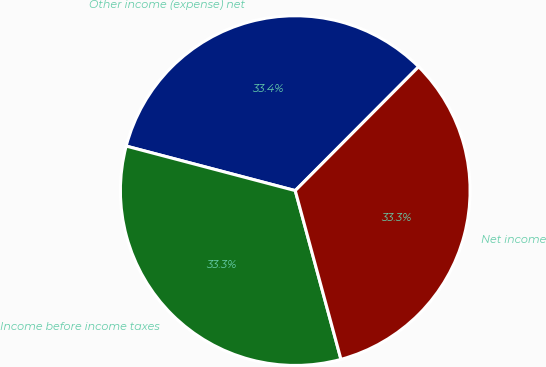Convert chart to OTSL. <chart><loc_0><loc_0><loc_500><loc_500><pie_chart><fcel>Other income (expense) net<fcel>Income before income taxes<fcel>Net income<nl><fcel>33.37%<fcel>33.31%<fcel>33.32%<nl></chart> 